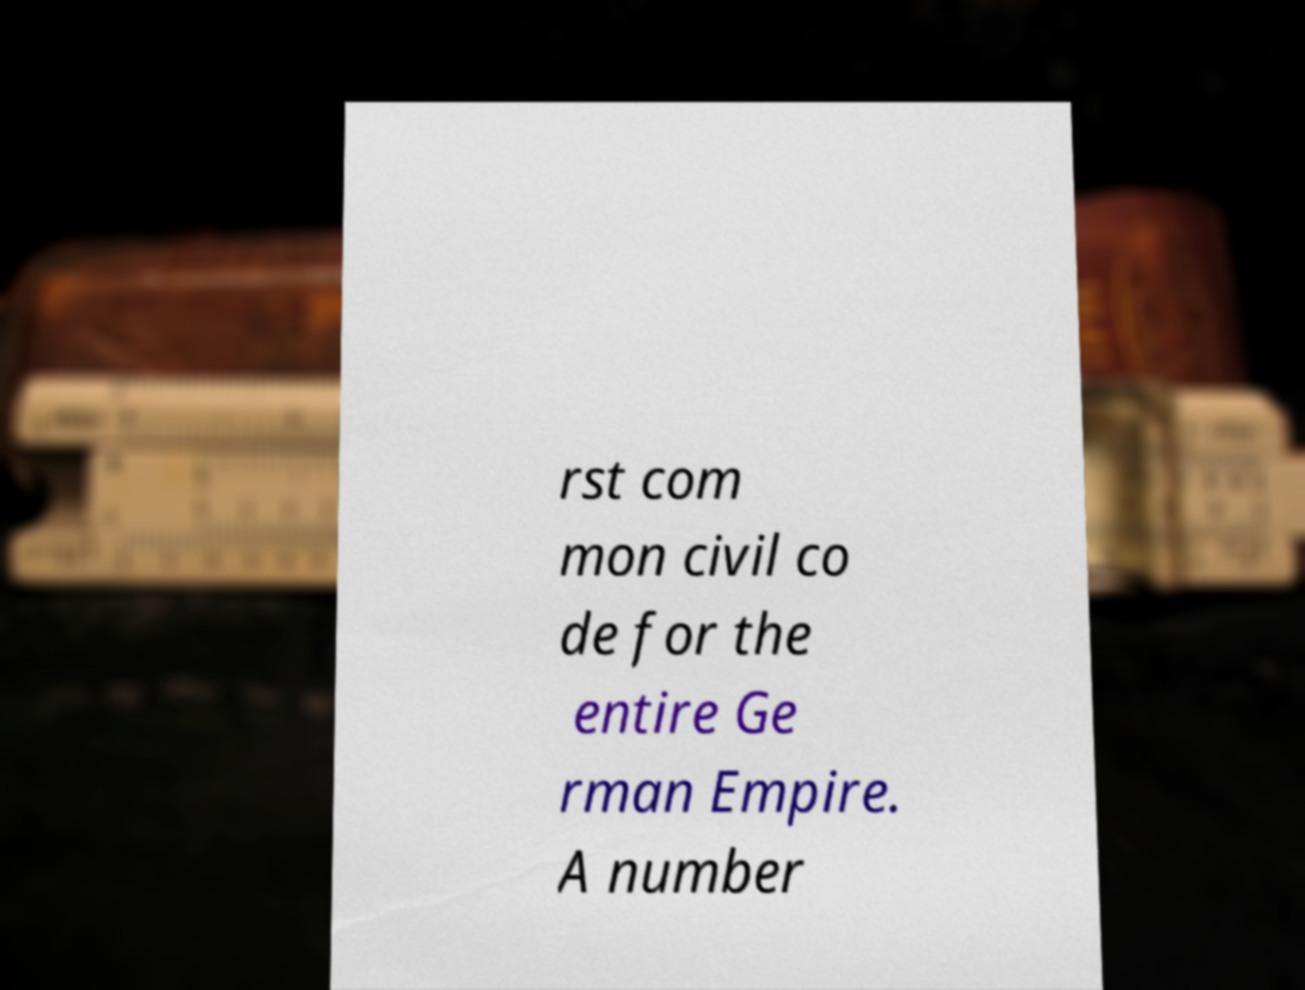Can you accurately transcribe the text from the provided image for me? rst com mon civil co de for the entire Ge rman Empire. A number 